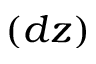Convert formula to latex. <formula><loc_0><loc_0><loc_500><loc_500>( d z )</formula> 